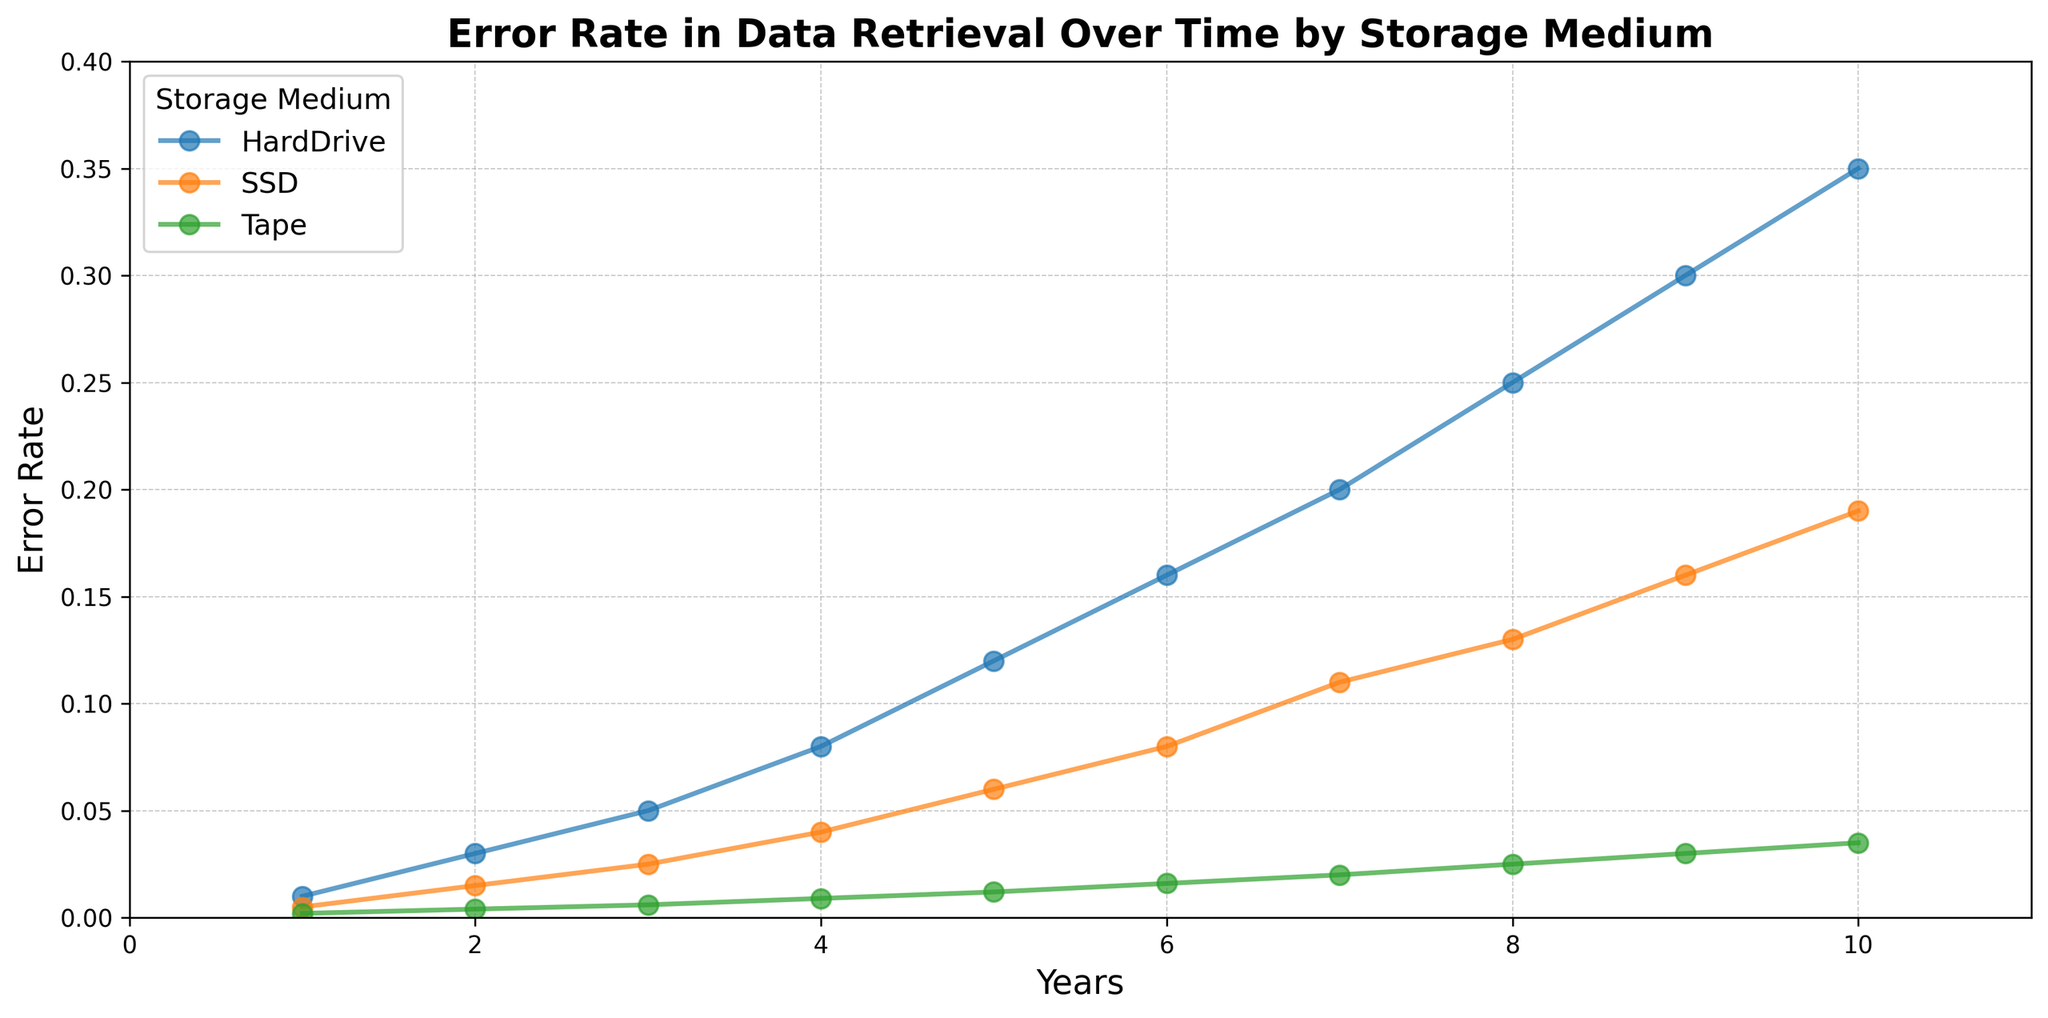What is the error rate of Hard Drives after 5 years? From the plot, locate the point corresponding to Hard Drives on the 5-year mark on the x-axis and identify the y-value.
Answer: 0.12 What is the difference in error rates between SSDs and Tapes in the 10th year? Identify the error rates for SSDs and Tapes at the 10-year mark. Subtract the Tape’s error rate from the SSD’s error rate to find the difference.
Answer: 0.19 - 0.035 = 0.155 Which storage medium has the lowest error rate in the first year? Examine the error rates for all storage media at the 1-year mark and identify the lowest value.
Answer: Tape Compare the error rates of Hard Drives and SSDs at the 6-year mark. Which one is higher? Look at the error rates for both Hard Drives and SSDs at the 6-year mark. Compare the values to determine which one is higher.
Answer: Hard Drives What is the average error rate of SSDs over the 10 years? Sum the error rates for SSDs over all 10 years and then divide by 10 to find the average.
Answer: (0.005 + 0.015 + 0.025 + 0.04 + 0.06 + 0.08 + 0.11 + 0.13 + 0.16 + 0.19) / 10 = 0.093 How much greater is the error rate of Hard Drives compared to Tapes in the 8th year? Determine the error rates for Hard Drives and Tapes at the 8-year mark. Subtract the Tape’s error rate from the Hard Drive’s error rate to find the difference.
Answer: 0.25 - 0.025 = 0.225 Which storage medium shows the fastest increase in error rate over time? Analyze the slopes of the lines for each storage medium to see which one has the steepest increase in error rate from year 1 to year 10.
Answer: Hard Drives What's the combined error rate of all media types in the 4th year? Add the error rates of Hard Drives, SSDs, and Tapes at the 4-year mark.
Answer: 0.08 + 0.04 + 0.009 = 0.129 Is there any year where SSDs have a higher error rate than Hard Drives? Compare the error rates of SSDs and Hard Drives for each year. Check if SSDs' error rate is higher in any year.
Answer: No 